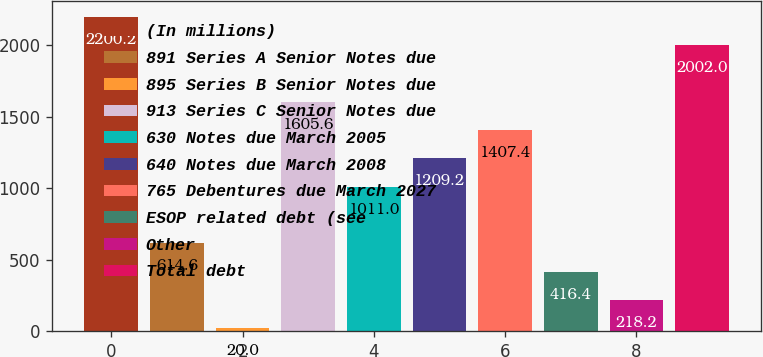Convert chart to OTSL. <chart><loc_0><loc_0><loc_500><loc_500><bar_chart><fcel>(In millions)<fcel>891 Series A Senior Notes due<fcel>895 Series B Senior Notes due<fcel>913 Series C Senior Notes due<fcel>630 Notes due March 2005<fcel>640 Notes due March 2008<fcel>765 Debentures due March 2027<fcel>ESOP related debt (see<fcel>Other<fcel>Total debt<nl><fcel>2200.2<fcel>614.6<fcel>20<fcel>1605.6<fcel>1011<fcel>1209.2<fcel>1407.4<fcel>416.4<fcel>218.2<fcel>2002<nl></chart> 